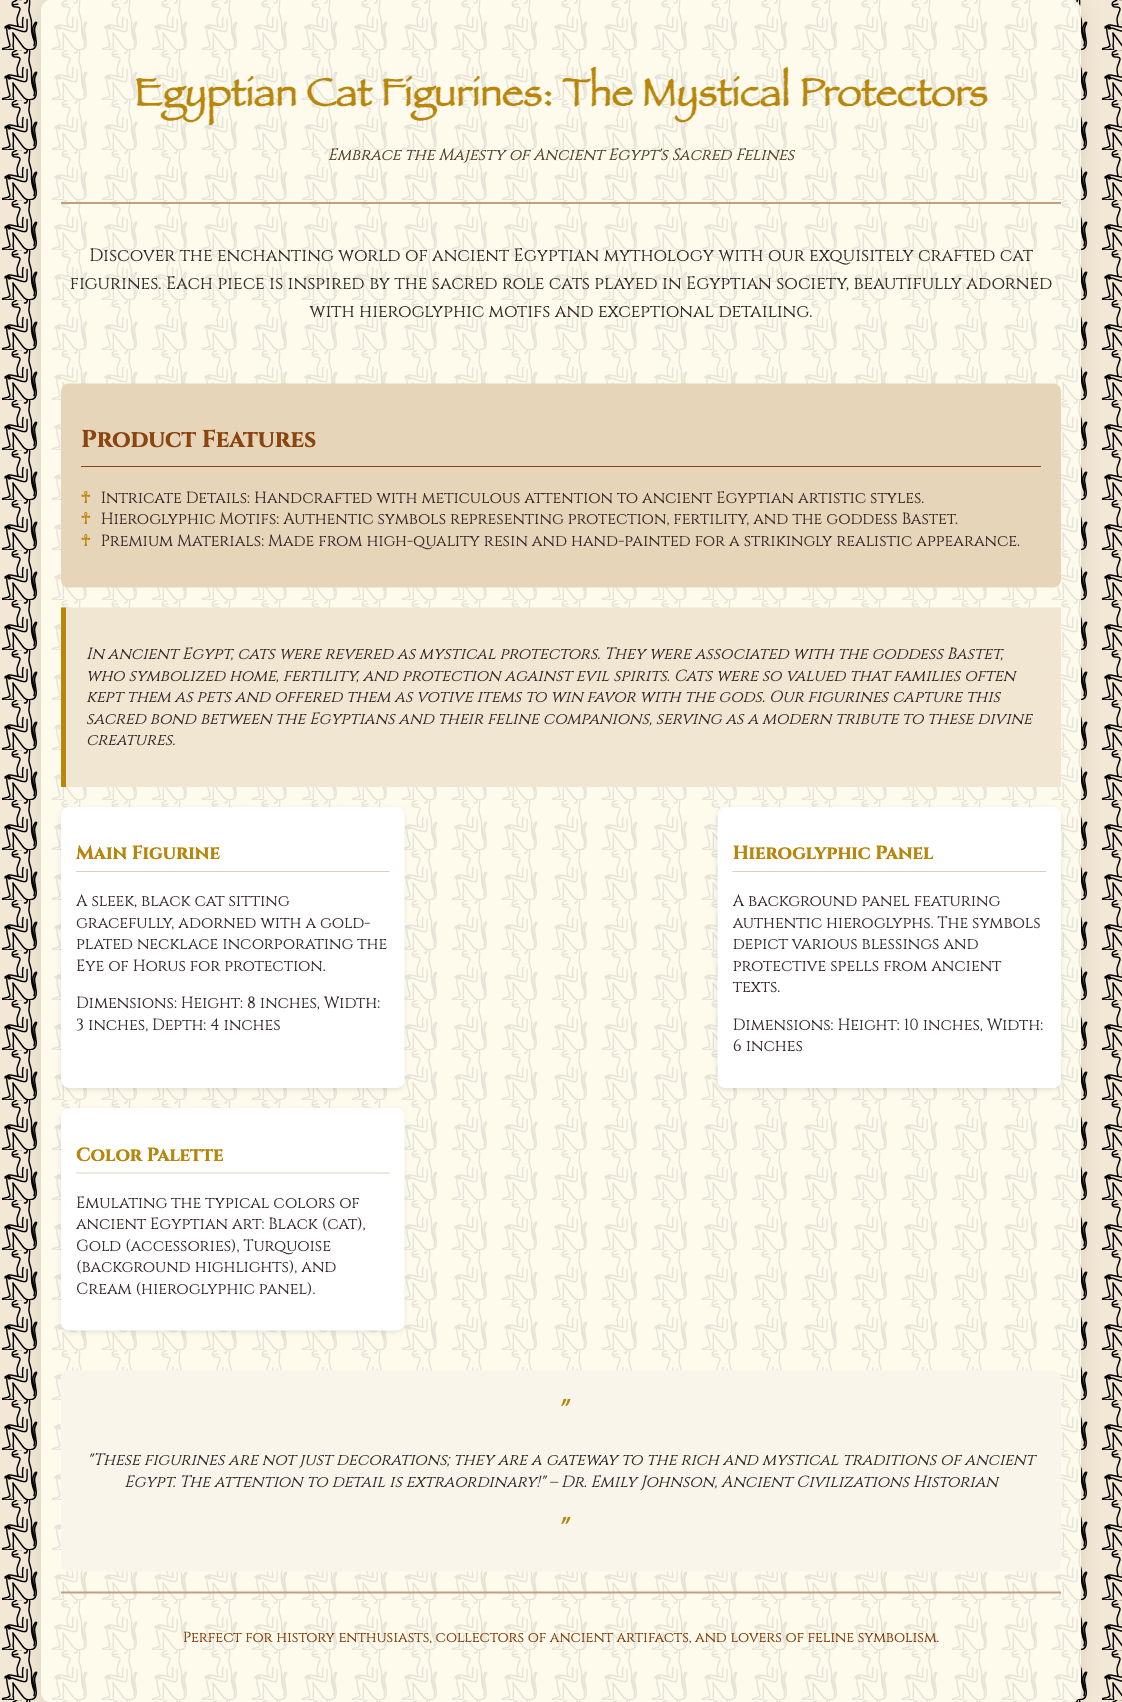What is the title of the product? The title of the product is prominently displayed at the top of the document.
Answer: Egyptian Cat Figurines: The Mystical Protectors Who is the goddess associated with cats in ancient Egypt? The document mentions the goddess associated with cats and her significance.
Answer: Bastet What materials are the figurines made from? The product features section lists the materials used in the creation of the figurines.
Answer: High-quality resin What dimension is specified for the main figurine? The dimensions for the main figurine are provided in the information section.
Answer: Height: 8 inches, Width: 3 inches, Depth: 4 inches What color is used for the cat figurine? The color palette section describes the color specifically attributed to the cat figurine.
Answer: Black What does the eye of Horus symbolize? The inclusion of this symbol is mentioned in relation to protection within the design elements.
Answer: Protection What is the primary function of the product according to the testimonial? The testimonial provides insight into what the product represents to the customer.
Answer: Gateway to traditions How are the figurines described in the background narrative? The background narrative section highlights the cultural significance of the cats in ancient Egypt.
Answer: Mystical protectors 